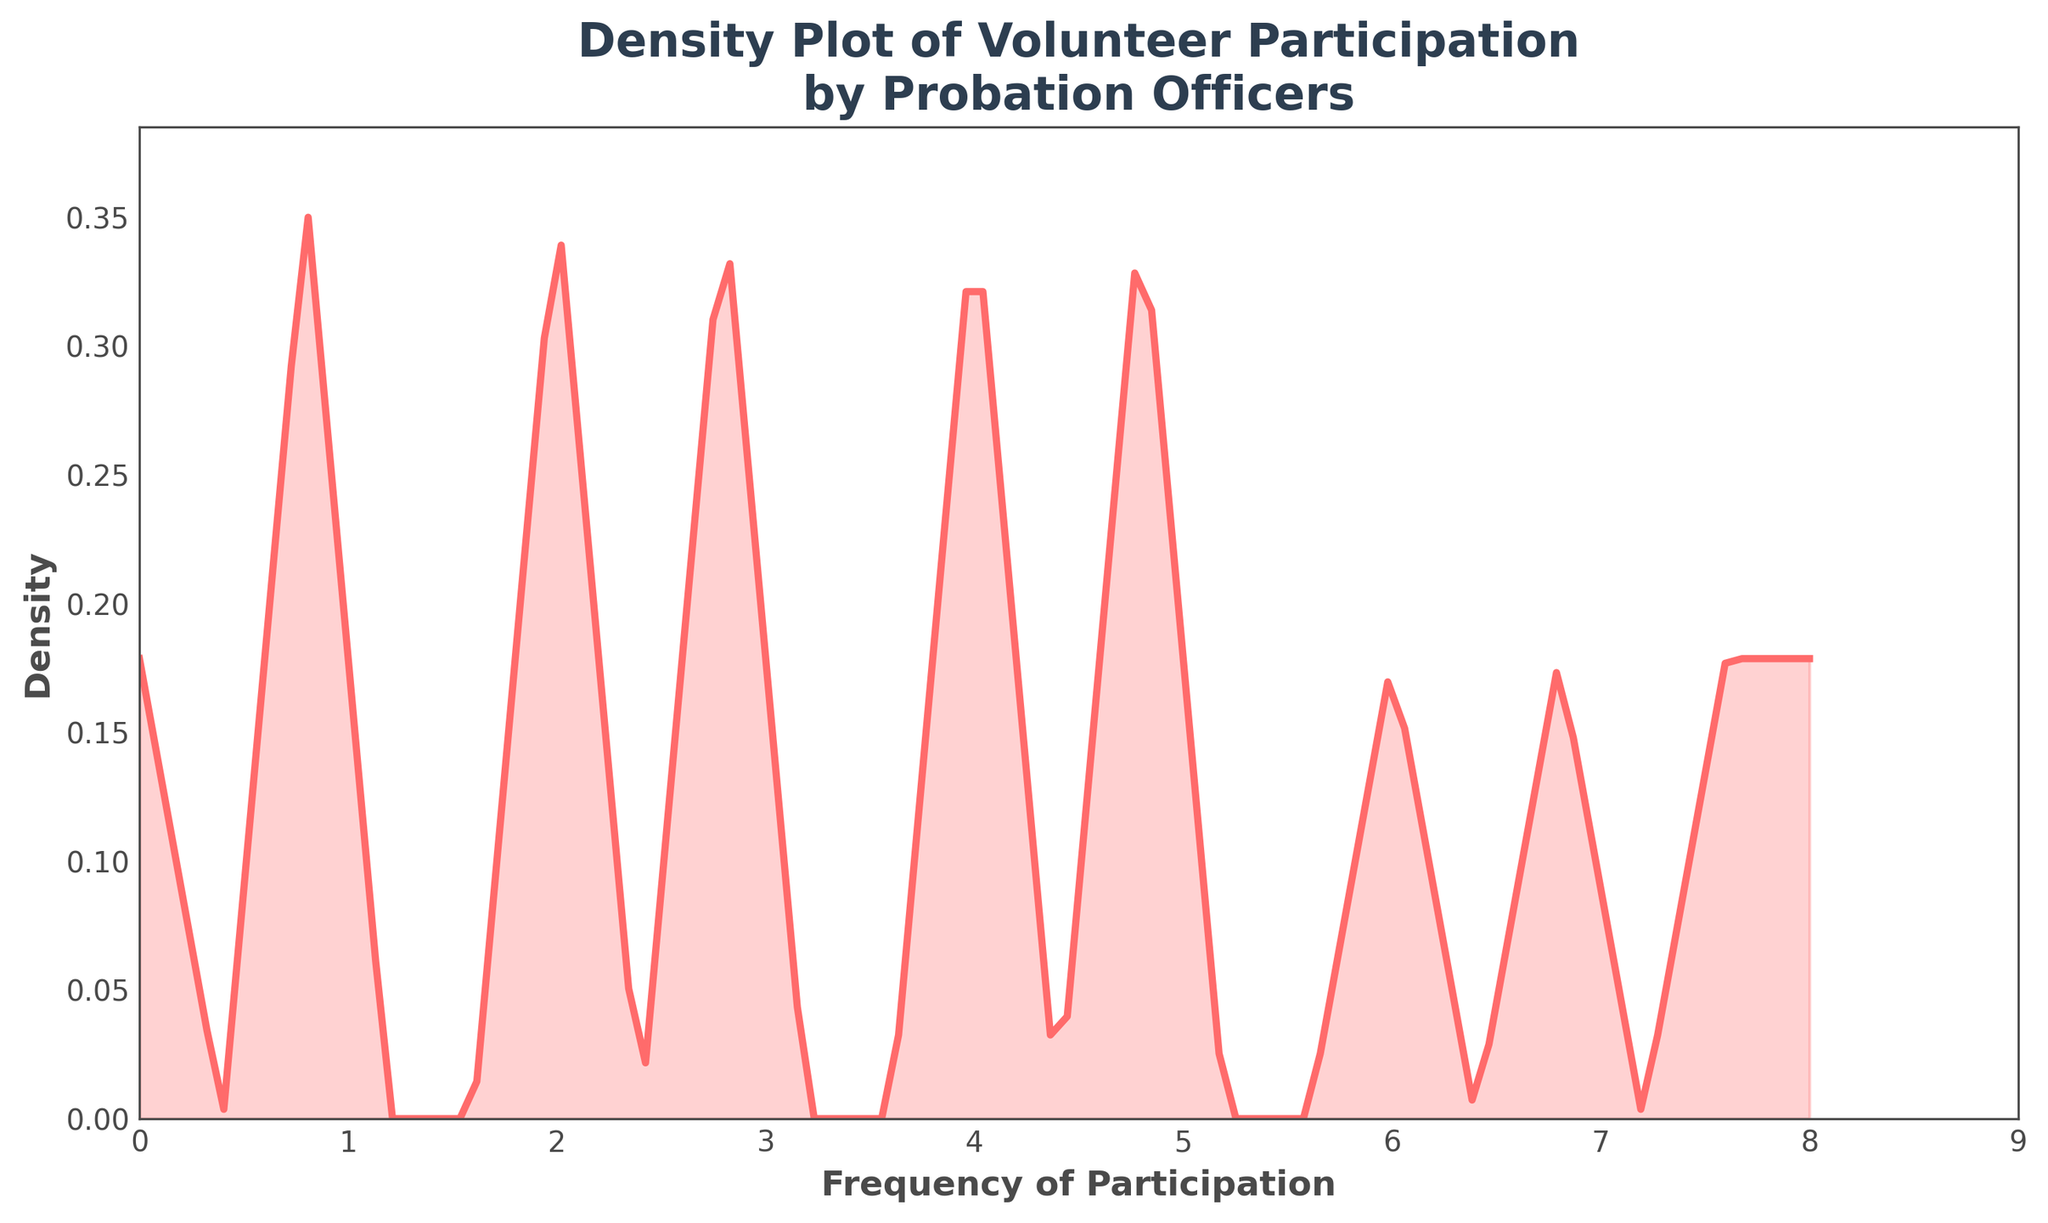What's the title of the plot? The title is usually found at the top of the plot. In this case, it reads "Density Plot of Volunteer Participation\nby Probation Officers"
Answer: Density Plot of Volunteer Participation by Probation Officers What are the x-axis and y-axis labels? The x-axis and y-axis labels are typically found along the horizontal and vertical axes. Here, the x-axis is labeled "Frequency of Participation" and the y-axis is labeled "Density."
Answer: Frequency of Participation, Density What is the color of the line in the plot? The color of the line can be observed visually. This line is a prominent color, specifically red.
Answer: Red What is the maximum frequency of participation shown in the plot? By observing the x-axis limit, you can see that the maximum value for frequency of participation on the x-axis is 8.
Answer: 8 Where does the plot peak, indicating the most common frequency of participation? Look for the highest point along the y-axis. The peak of the density plot appears around the frequency of 2 and 3 on the x-axis.
Answer: Around 2 and 3 How does the frequency of 1 compare to the frequency of 7? Compare the height of the curve at these points. The density at frequency 1 is higher than at frequency 7.
Answer: Higher What is the visual difference between the frequency 0 and frequency 8 in terms of density? By comparing the height of the curve at these points, you can see that the density at frequency 0 is lower than the density at frequency 8.
Answer: Lower What does the filled area under the curve represent? The filled area represents the density of volunteer participation frequencies by probation officers. The area shows where the frequencies are concentrated.
Answer: Density of frequencies What range of frequencies has the highest density? Observe the section where the curve is the highest. The highest density appears to be between the frequencies 2 and 3.
Answer: Between 2 and 3 Are there any frequencies with a density of zero? Check if the curve touches the x-axis at any point. The density does not drop to zero at any given frequency within the visible range.
Answer: No 